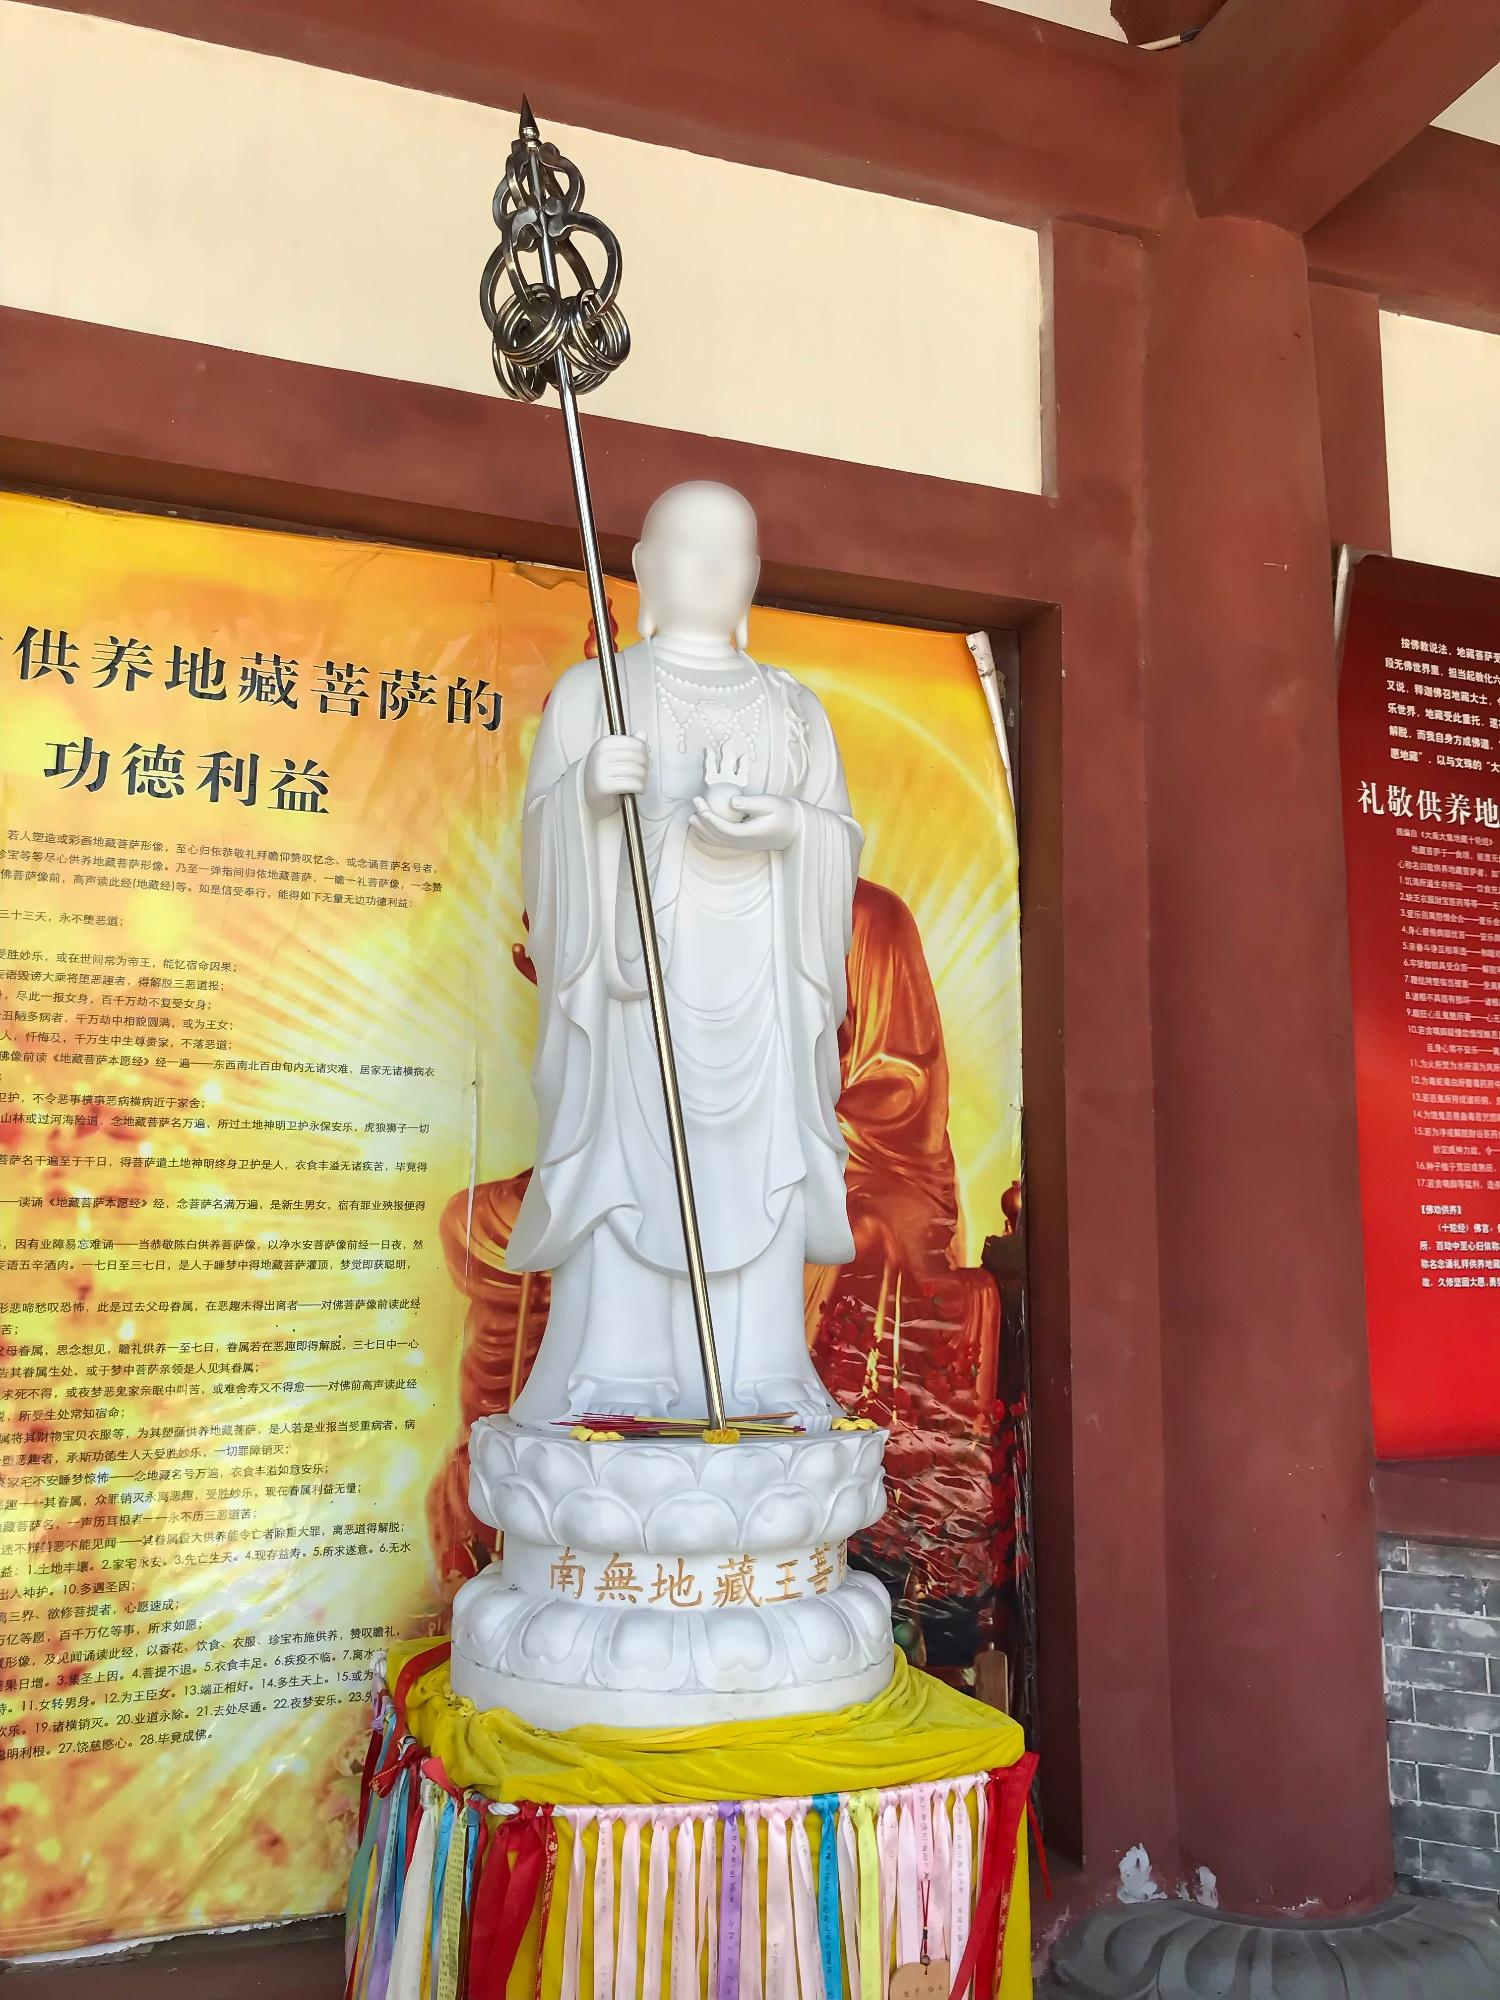Describe the following image. The image captures a serene scene of a Buddhist temple. Dominating the frame is a white statue of a Buddhist monk, who holds a staff crowned with a lotus flower. The statue stands on a white pedestal, which is adorned with Chinese characters. The pedestal itself is placed on a vibrant platform draped in red, yellow, and blue fabric, adding a splash of color to the scene.

The backdrop is a red wall, also inscribed with Chinese characters, and a yellow banner with more Chinese characters. The phrase "功德无量" is prominently displayed, a common Buddhist saying that translates to "boundless virtuous deeds."

The perspective of the photo is particularly striking, taken from a low angle that directs the viewer's gaze upwards towards the statue, enhancing its grandeur and spiritual significance. The composition of the image, with its vivid colors and symbolic elements, paints a picture of a place steeped in tradition and spirituality. 